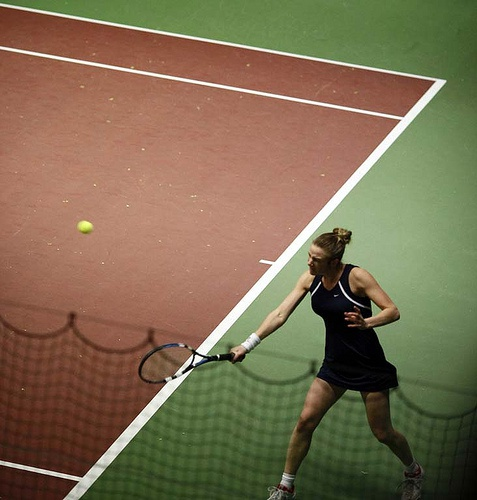Describe the objects in this image and their specific colors. I can see people in darkgreen, black, olive, tan, and gray tones, tennis racket in darkgreen, brown, gray, and black tones, and sports ball in darkgreen, tan, khaki, and olive tones in this image. 